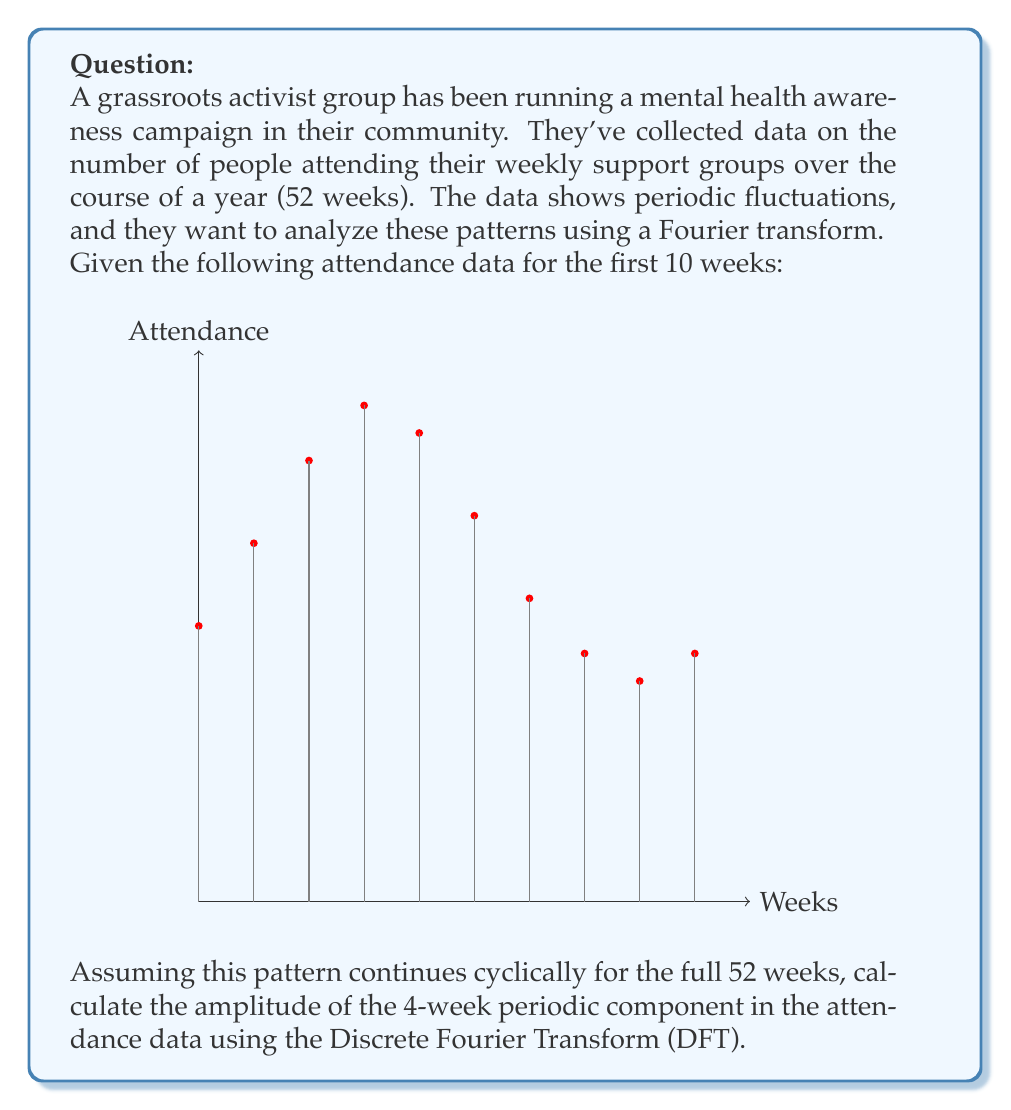Provide a solution to this math problem. To solve this problem, we'll follow these steps:

1) First, we need to understand that the 4-week periodic component corresponds to a frequency of 13 cycles per year (52 weeks / 4 weeks = 13).

2) The Discrete Fourier Transform for a sequence $x_n$ of N points is given by:

   $$X_k = \sum_{n=0}^{N-1} x_n e^{-i2\pi kn/N}$$

   where $k = 0, 1, ..., N-1$

3) In our case, $N = 52$ (total weeks), and we're interested in $k = 13$ (the 4-week periodic component).

4) We don't have all 52 data points, but we're told the pattern repeats. So we can use the 10 points we have and repeat them:

   $x_n = \{50, 65, 80, 90, 85, 70, 55, 45, 40, 45, 50, 65, ...\}$

5) Plugging this into the DFT formula:

   $$X_{13} = \sum_{n=0}^{51} x_n e^{-i2\pi \cdot 13 \cdot n/52}$$

6) This can be simplified due to the cyclic nature of the data:

   $$X_{13} = \sum_{n=0}^{9} x_n (e^{-i2\pi \cdot 13 \cdot n/52} + e^{-i2\pi \cdot 13 \cdot (n+10)/52} + e^{-i2\pi \cdot 13 \cdot (n+20)/52} + e^{-i2\pi \cdot 13 \cdot (n+30)/52} + e^{-i2\pi \cdot 13 \cdot (n+40)/52})$$

7) Simplify the exponentials:

   $$X_{13} = \sum_{n=0}^{9} x_n e^{-i2\pi \cdot 13 \cdot n/52} (1 + e^{-i2\pi \cdot 13 \cdot 10/52} + e^{-i2\pi \cdot 13 \cdot 20/52} + e^{-i2\pi \cdot 13 \cdot 30/52} + e^{-i2\pi \cdot 13 \cdot 40/52})$$

8) Calculate this sum (which would typically be done with a computer).

9) The amplitude of this frequency component is given by $|X_{13}|/26$ (dividing by N/2 = 52/2 = 26).
Answer: $|X_{13}|/26 \approx 11.54$ 